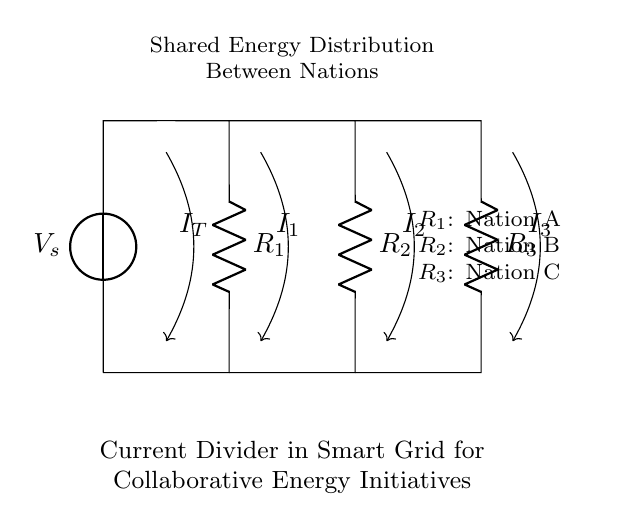What is the total current in this circuit? The total current is denoted as I_T and shown in the circuit as flowing from the current source to the connected resistors.
Answer: I_T Which resistors are involved in the current divider? The current divider consists of three resistors: R_1, R_2, and R_3. These are connected in parallel, dividing the total current.
Answer: R_1, R_2, R_3 What role do R_1, R_2, and R_3 represent? Each resistor represents a different nation collaborating in the smart grid: R_1 is Nation A, R_2 is Nation B, and R_3 is Nation C.
Answer: Nation A, Nation B, Nation C How does the current divide among the resistors? The current divides inversely proportional to the resistance values according to the current divider rule: the lower the resistance, the higher the current through that path.
Answer: Inversely proportional What is the purpose of this current divider in the context of smart grid technology? The current divider is used for collaborative energy distribution between nations, allowing for shared energy resources effectively among them.
Answer: Collaborative energy distribution Which nation would receive the highest current if all resistances are equal? If all resistances are equal, the current would divide equally among the nations.
Answer: Equal division 